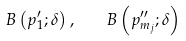<formula> <loc_0><loc_0><loc_500><loc_500>B \left ( p _ { 1 } ^ { \prime } ; \delta \right ) , \quad B \left ( p _ { m _ { j } } ^ { \prime \prime } ; \delta \right )</formula> 